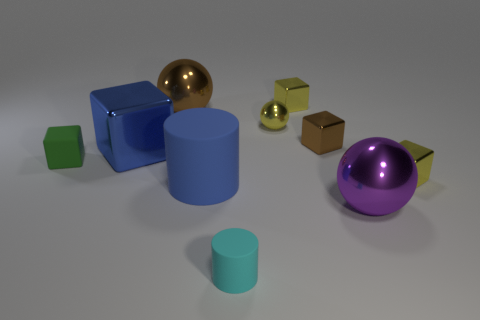Subtract all small yellow spheres. How many spheres are left? 2 Subtract all purple spheres. How many spheres are left? 2 Subtract all cyan cubes. How many blue spheres are left? 0 Subtract all large blocks. Subtract all green matte objects. How many objects are left? 8 Add 9 large blue shiny things. How many large blue shiny things are left? 10 Add 8 matte cubes. How many matte cubes exist? 9 Subtract 1 purple spheres. How many objects are left? 9 Subtract all balls. How many objects are left? 7 Subtract 3 spheres. How many spheres are left? 0 Subtract all cyan cylinders. Subtract all red blocks. How many cylinders are left? 1 